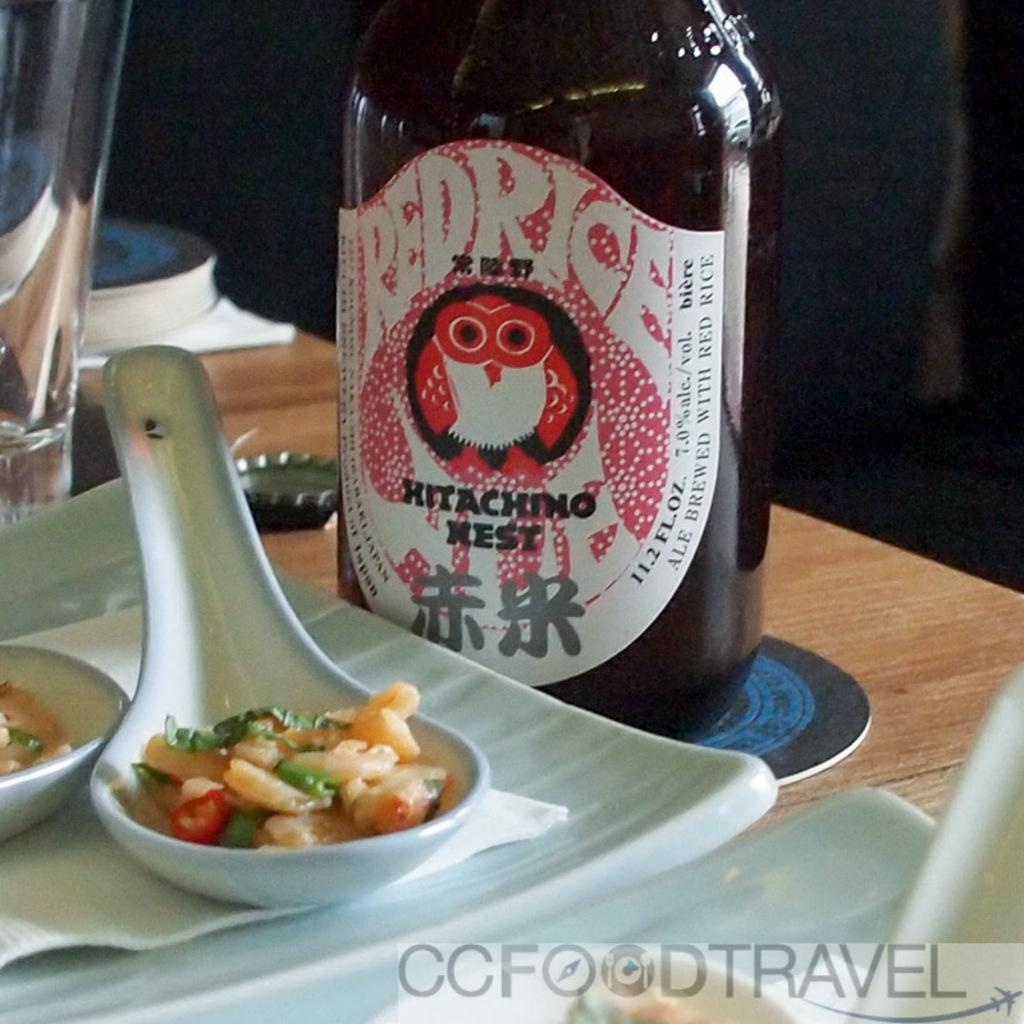Provide a one-sentence caption for the provided image. a bottle of redrice hitachino nest sitting next to a spoonful of food. 